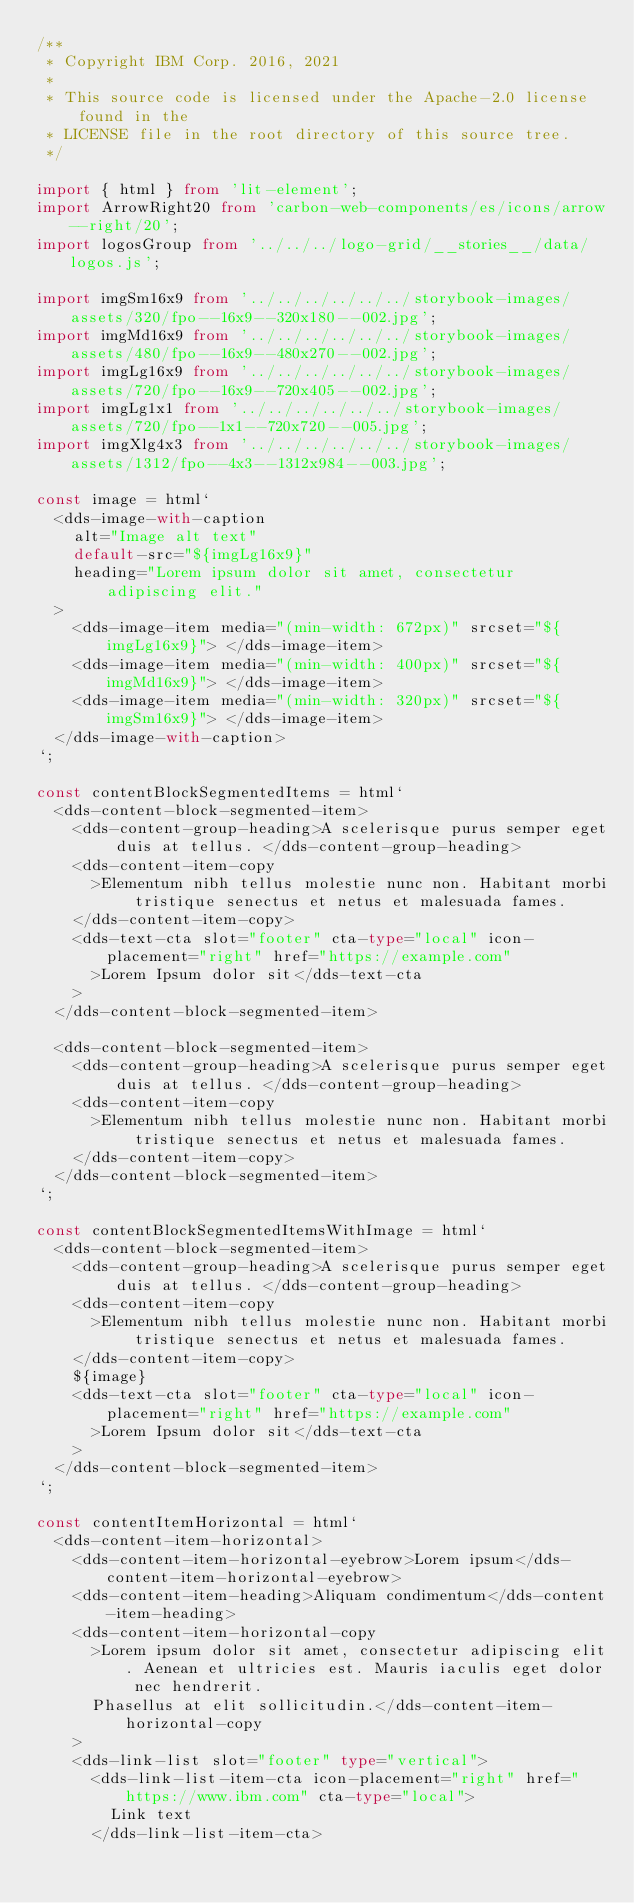<code> <loc_0><loc_0><loc_500><loc_500><_TypeScript_>/**
 * Copyright IBM Corp. 2016, 2021
 *
 * This source code is licensed under the Apache-2.0 license found in the
 * LICENSE file in the root directory of this source tree.
 */

import { html } from 'lit-element';
import ArrowRight20 from 'carbon-web-components/es/icons/arrow--right/20';
import logosGroup from '../../../logo-grid/__stories__/data/logos.js';

import imgSm16x9 from '../../../../../../storybook-images/assets/320/fpo--16x9--320x180--002.jpg';
import imgMd16x9 from '../../../../../../storybook-images/assets/480/fpo--16x9--480x270--002.jpg';
import imgLg16x9 from '../../../../../../storybook-images/assets/720/fpo--16x9--720x405--002.jpg';
import imgLg1x1 from '../../../../../../storybook-images/assets/720/fpo--1x1--720x720--005.jpg';
import imgXlg4x3 from '../../../../../../storybook-images/assets/1312/fpo--4x3--1312x984--003.jpg';

const image = html`
  <dds-image-with-caption
    alt="Image alt text"
    default-src="${imgLg16x9}"
    heading="Lorem ipsum dolor sit amet, consectetur adipiscing elit."
  >
    <dds-image-item media="(min-width: 672px)" srcset="${imgLg16x9}"> </dds-image-item>
    <dds-image-item media="(min-width: 400px)" srcset="${imgMd16x9}"> </dds-image-item>
    <dds-image-item media="(min-width: 320px)" srcset="${imgSm16x9}"> </dds-image-item>
  </dds-image-with-caption>
`;

const contentBlockSegmentedItems = html`
  <dds-content-block-segmented-item>
    <dds-content-group-heading>A scelerisque purus semper eget duis at tellus. </dds-content-group-heading>
    <dds-content-item-copy
      >Elementum nibh tellus molestie nunc non. Habitant morbi tristique senectus et netus et malesuada fames.
    </dds-content-item-copy>
    <dds-text-cta slot="footer" cta-type="local" icon-placement="right" href="https://example.com"
      >Lorem Ipsum dolor sit</dds-text-cta
    >
  </dds-content-block-segmented-item>

  <dds-content-block-segmented-item>
    <dds-content-group-heading>A scelerisque purus semper eget duis at tellus. </dds-content-group-heading>
    <dds-content-item-copy
      >Elementum nibh tellus molestie nunc non. Habitant morbi tristique senectus et netus et malesuada fames.
    </dds-content-item-copy>
  </dds-content-block-segmented-item>
`;

const contentBlockSegmentedItemsWithImage = html`
  <dds-content-block-segmented-item>
    <dds-content-group-heading>A scelerisque purus semper eget duis at tellus. </dds-content-group-heading>
    <dds-content-item-copy
      >Elementum nibh tellus molestie nunc non. Habitant morbi tristique senectus et netus et malesuada fames.
    </dds-content-item-copy>
    ${image}
    <dds-text-cta slot="footer" cta-type="local" icon-placement="right" href="https://example.com"
      >Lorem Ipsum dolor sit</dds-text-cta
    >
  </dds-content-block-segmented-item>
`;

const contentItemHorizontal = html`
  <dds-content-item-horizontal>
    <dds-content-item-horizontal-eyebrow>Lorem ipsum</dds-content-item-horizontal-eyebrow>
    <dds-content-item-heading>Aliquam condimentum</dds-content-item-heading>
    <dds-content-item-horizontal-copy
      >Lorem ipsum dolor sit amet, consectetur adipiscing elit. Aenean et ultricies est. Mauris iaculis eget dolor nec hendrerit.
      Phasellus at elit sollicitudin.</dds-content-item-horizontal-copy
    >
    <dds-link-list slot="footer" type="vertical">
      <dds-link-list-item-cta icon-placement="right" href="https://www.ibm.com" cta-type="local">
        Link text
      </dds-link-list-item-cta></code> 